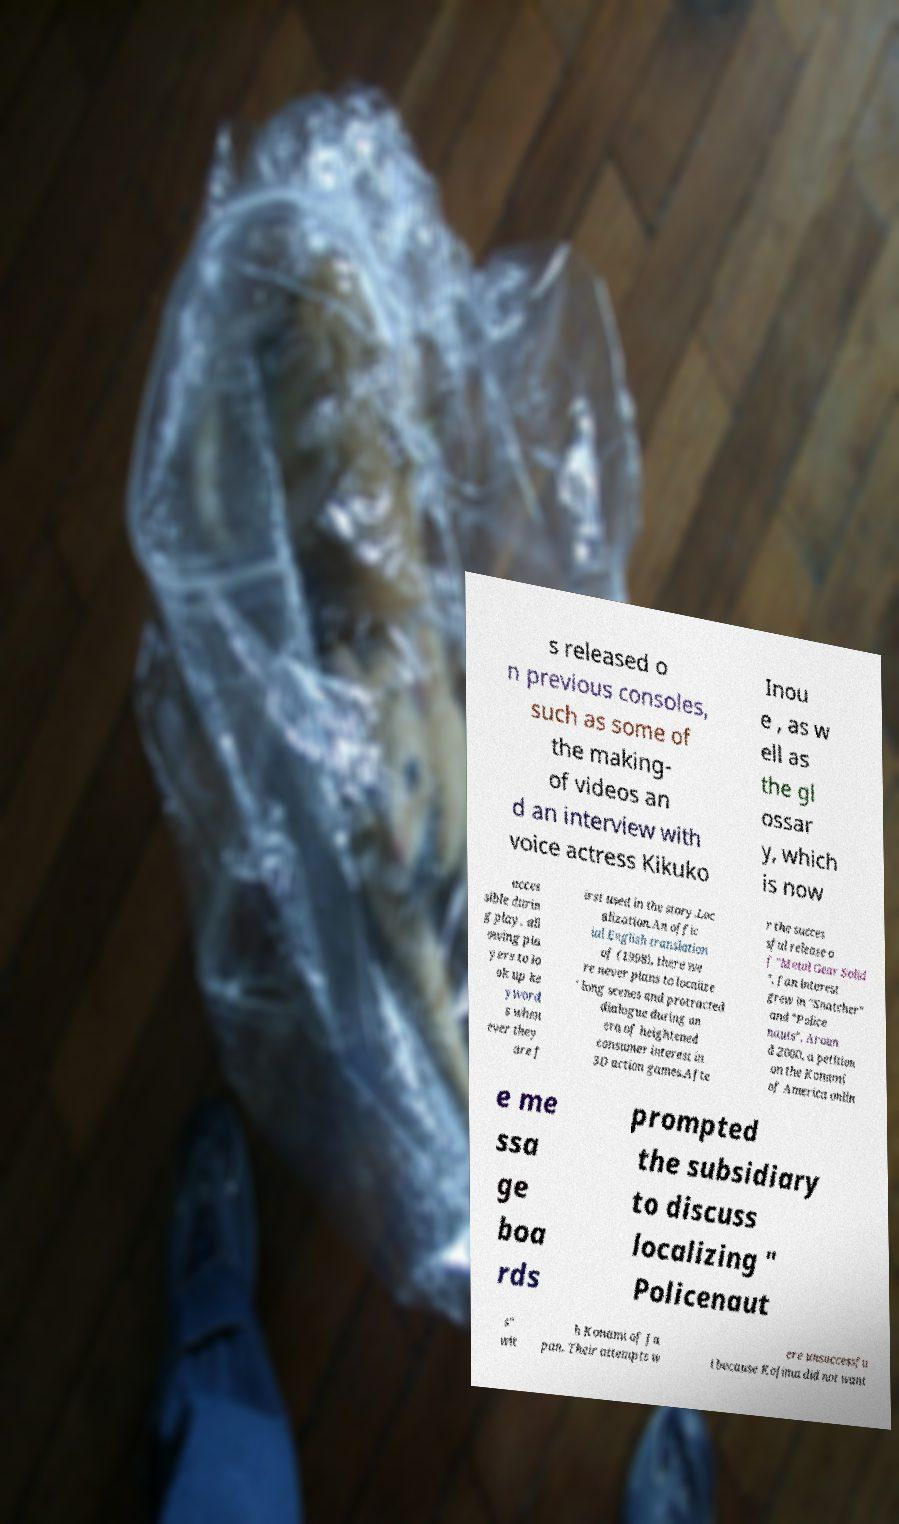Can you accurately transcribe the text from the provided image for me? s released o n previous consoles, such as some of the making- of videos an d an interview with voice actress Kikuko Inou e , as w ell as the gl ossar y, which is now acces sible durin g play, all owing pla yers to lo ok up ke yword s when ever they are f irst used in the story.Loc alization.An offic ial English translation of (1998), there we re never plans to localize ' long scenes and protracted dialogue during an era of heightened consumer interest in 3D action games.Afte r the succes sful release o f "Metal Gear Solid ", fan interest grew in "Snatcher" and "Police nauts". Aroun d 2000, a petition on the Konami of America onlin e me ssa ge boa rds prompted the subsidiary to discuss localizing " Policenaut s" wit h Konami of Ja pan. Their attempts w ere unsuccessfu l because Kojima did not want 